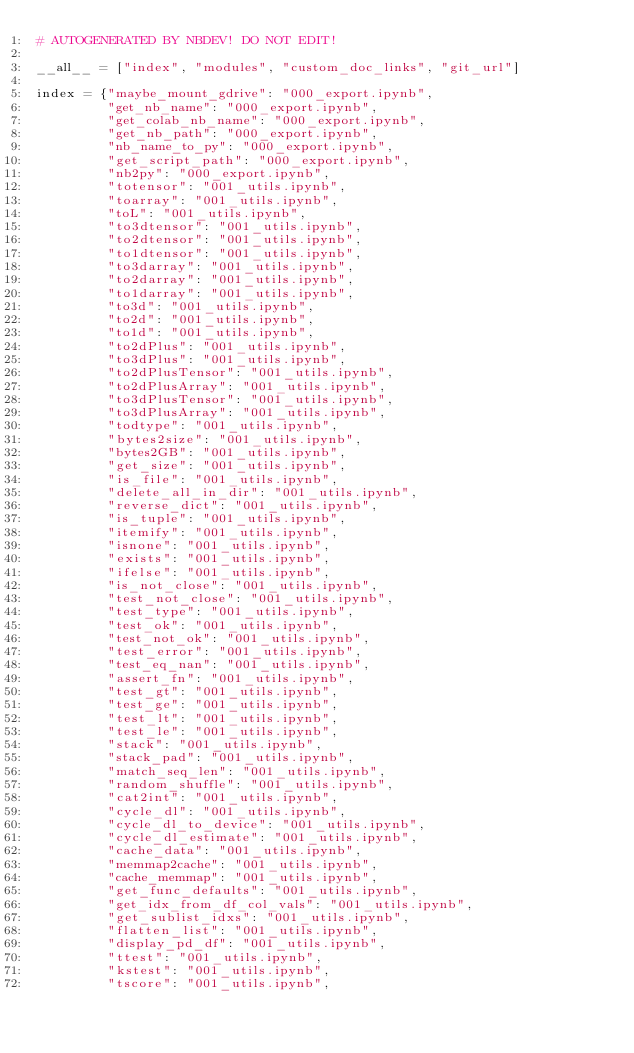<code> <loc_0><loc_0><loc_500><loc_500><_Python_># AUTOGENERATED BY NBDEV! DO NOT EDIT!

__all__ = ["index", "modules", "custom_doc_links", "git_url"]

index = {"maybe_mount_gdrive": "000_export.ipynb",
         "get_nb_name": "000_export.ipynb",
         "get_colab_nb_name": "000_export.ipynb",
         "get_nb_path": "000_export.ipynb",
         "nb_name_to_py": "000_export.ipynb",
         "get_script_path": "000_export.ipynb",
         "nb2py": "000_export.ipynb",
         "totensor": "001_utils.ipynb",
         "toarray": "001_utils.ipynb",
         "toL": "001_utils.ipynb",
         "to3dtensor": "001_utils.ipynb",
         "to2dtensor": "001_utils.ipynb",
         "to1dtensor": "001_utils.ipynb",
         "to3darray": "001_utils.ipynb",
         "to2darray": "001_utils.ipynb",
         "to1darray": "001_utils.ipynb",
         "to3d": "001_utils.ipynb",
         "to2d": "001_utils.ipynb",
         "to1d": "001_utils.ipynb",
         "to2dPlus": "001_utils.ipynb",
         "to3dPlus": "001_utils.ipynb",
         "to2dPlusTensor": "001_utils.ipynb",
         "to2dPlusArray": "001_utils.ipynb",
         "to3dPlusTensor": "001_utils.ipynb",
         "to3dPlusArray": "001_utils.ipynb",
         "todtype": "001_utils.ipynb",
         "bytes2size": "001_utils.ipynb",
         "bytes2GB": "001_utils.ipynb",
         "get_size": "001_utils.ipynb",
         "is_file": "001_utils.ipynb",
         "delete_all_in_dir": "001_utils.ipynb",
         "reverse_dict": "001_utils.ipynb",
         "is_tuple": "001_utils.ipynb",
         "itemify": "001_utils.ipynb",
         "isnone": "001_utils.ipynb",
         "exists": "001_utils.ipynb",
         "ifelse": "001_utils.ipynb",
         "is_not_close": "001_utils.ipynb",
         "test_not_close": "001_utils.ipynb",
         "test_type": "001_utils.ipynb",
         "test_ok": "001_utils.ipynb",
         "test_not_ok": "001_utils.ipynb",
         "test_error": "001_utils.ipynb",
         "test_eq_nan": "001_utils.ipynb",
         "assert_fn": "001_utils.ipynb",
         "test_gt": "001_utils.ipynb",
         "test_ge": "001_utils.ipynb",
         "test_lt": "001_utils.ipynb",
         "test_le": "001_utils.ipynb",
         "stack": "001_utils.ipynb",
         "stack_pad": "001_utils.ipynb",
         "match_seq_len": "001_utils.ipynb",
         "random_shuffle": "001_utils.ipynb",
         "cat2int": "001_utils.ipynb",
         "cycle_dl": "001_utils.ipynb",
         "cycle_dl_to_device": "001_utils.ipynb",
         "cycle_dl_estimate": "001_utils.ipynb",
         "cache_data": "001_utils.ipynb",
         "memmap2cache": "001_utils.ipynb",
         "cache_memmap": "001_utils.ipynb",
         "get_func_defaults": "001_utils.ipynb",
         "get_idx_from_df_col_vals": "001_utils.ipynb",
         "get_sublist_idxs": "001_utils.ipynb",
         "flatten_list": "001_utils.ipynb",
         "display_pd_df": "001_utils.ipynb",
         "ttest": "001_utils.ipynb",
         "kstest": "001_utils.ipynb",
         "tscore": "001_utils.ipynb",</code> 